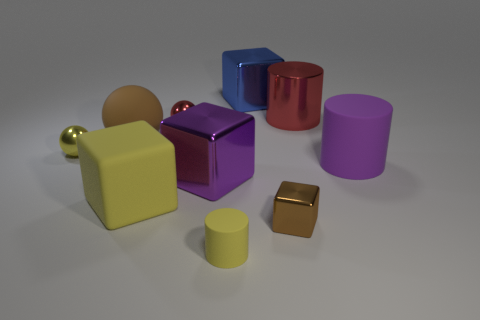Subtract all big rubber cubes. How many cubes are left? 3 Subtract 1 cubes. How many cubes are left? 3 Subtract all blue cubes. How many cubes are left? 3 Subtract all blocks. How many objects are left? 6 Subtract 1 yellow spheres. How many objects are left? 9 Subtract all purple cubes. Subtract all purple cylinders. How many cubes are left? 3 Subtract all metal objects. Subtract all tiny red spheres. How many objects are left? 3 Add 4 big cubes. How many big cubes are left? 7 Add 5 small metallic things. How many small metallic things exist? 8 